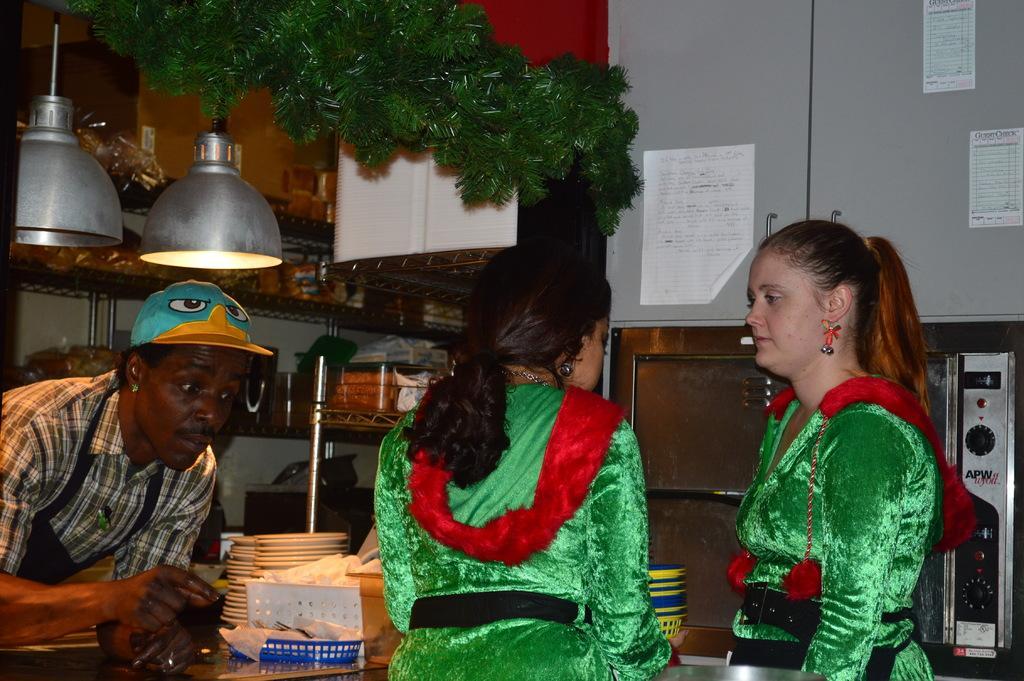Describe this image in one or two sentences. In this image, we can see two ladies standing and there is a man on the left. At the top, we can see a garland and there are lights, papers pasted on the rack and there are some bowls and tissues on the table. 